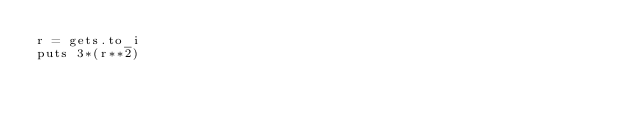Convert code to text. <code><loc_0><loc_0><loc_500><loc_500><_Ruby_>r = gets.to_i
puts 3*(r**2)</code> 